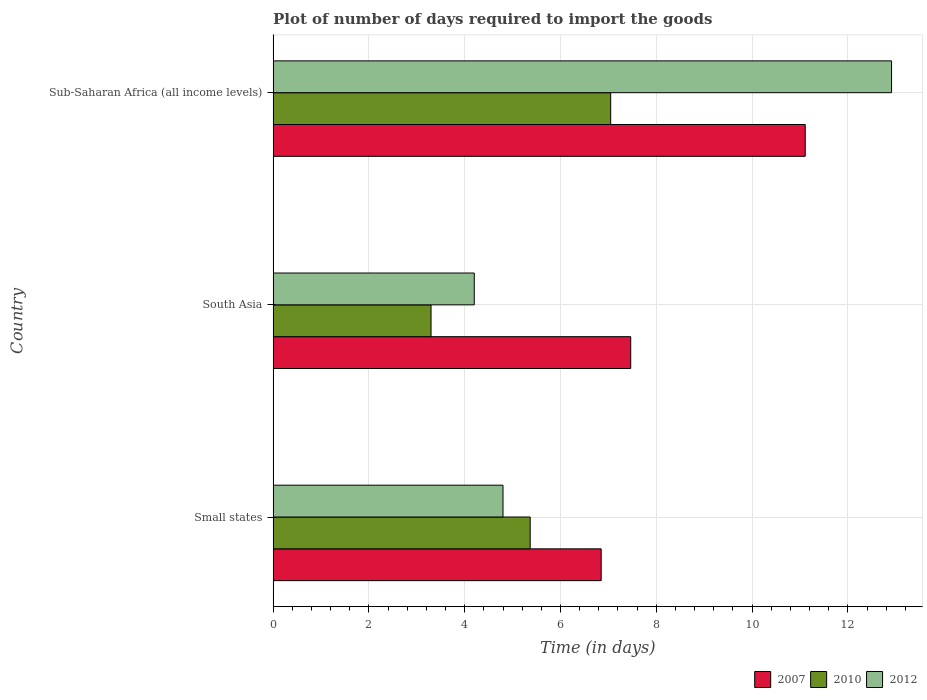How many different coloured bars are there?
Give a very brief answer. 3. Are the number of bars on each tick of the Y-axis equal?
Provide a short and direct response. Yes. How many bars are there on the 3rd tick from the top?
Give a very brief answer. 3. How many bars are there on the 3rd tick from the bottom?
Keep it short and to the point. 3. What is the label of the 1st group of bars from the top?
Your answer should be compact. Sub-Saharan Africa (all income levels). In how many cases, is the number of bars for a given country not equal to the number of legend labels?
Give a very brief answer. 0. Across all countries, what is the maximum time required to import goods in 2012?
Ensure brevity in your answer.  12.91. Across all countries, what is the minimum time required to import goods in 2010?
Provide a short and direct response. 3.3. In which country was the time required to import goods in 2007 maximum?
Offer a very short reply. Sub-Saharan Africa (all income levels). In which country was the time required to import goods in 2007 minimum?
Provide a short and direct response. Small states. What is the total time required to import goods in 2007 in the graph?
Ensure brevity in your answer.  25.43. What is the difference between the time required to import goods in 2010 in South Asia and that in Sub-Saharan Africa (all income levels)?
Offer a terse response. -3.75. What is the difference between the time required to import goods in 2010 in Sub-Saharan Africa (all income levels) and the time required to import goods in 2007 in Small states?
Your response must be concise. 0.2. What is the average time required to import goods in 2010 per country?
Provide a short and direct response. 5.24. What is the difference between the time required to import goods in 2010 and time required to import goods in 2007 in South Asia?
Your response must be concise. -4.17. What is the ratio of the time required to import goods in 2007 in Small states to that in South Asia?
Offer a very short reply. 0.92. Is the time required to import goods in 2007 in Small states less than that in Sub-Saharan Africa (all income levels)?
Make the answer very short. Yes. What is the difference between the highest and the second highest time required to import goods in 2007?
Offer a very short reply. 3.64. What is the difference between the highest and the lowest time required to import goods in 2012?
Keep it short and to the point. 8.71. In how many countries, is the time required to import goods in 2012 greater than the average time required to import goods in 2012 taken over all countries?
Offer a very short reply. 1. What does the 2nd bar from the top in South Asia represents?
Ensure brevity in your answer.  2010. Is it the case that in every country, the sum of the time required to import goods in 2012 and time required to import goods in 2007 is greater than the time required to import goods in 2010?
Give a very brief answer. Yes. How many countries are there in the graph?
Make the answer very short. 3. Where does the legend appear in the graph?
Ensure brevity in your answer.  Bottom right. What is the title of the graph?
Give a very brief answer. Plot of number of days required to import the goods. Does "1967" appear as one of the legend labels in the graph?
Your answer should be very brief. No. What is the label or title of the X-axis?
Make the answer very short. Time (in days). What is the Time (in days) of 2007 in Small states?
Your answer should be compact. 6.85. What is the Time (in days) in 2010 in Small states?
Keep it short and to the point. 5.37. What is the Time (in days) in 2012 in Small states?
Offer a terse response. 4.8. What is the Time (in days) of 2007 in South Asia?
Give a very brief answer. 7.47. What is the Time (in days) of 2010 in South Asia?
Ensure brevity in your answer.  3.3. What is the Time (in days) of 2012 in South Asia?
Offer a very short reply. 4.2. What is the Time (in days) of 2007 in Sub-Saharan Africa (all income levels)?
Your answer should be very brief. 11.11. What is the Time (in days) of 2010 in Sub-Saharan Africa (all income levels)?
Offer a terse response. 7.05. What is the Time (in days) in 2012 in Sub-Saharan Africa (all income levels)?
Keep it short and to the point. 12.91. Across all countries, what is the maximum Time (in days) of 2007?
Ensure brevity in your answer.  11.11. Across all countries, what is the maximum Time (in days) in 2010?
Your response must be concise. 7.05. Across all countries, what is the maximum Time (in days) in 2012?
Provide a short and direct response. 12.91. Across all countries, what is the minimum Time (in days) of 2007?
Ensure brevity in your answer.  6.85. Across all countries, what is the minimum Time (in days) of 2010?
Make the answer very short. 3.3. Across all countries, what is the minimum Time (in days) in 2012?
Your answer should be compact. 4.2. What is the total Time (in days) in 2007 in the graph?
Keep it short and to the point. 25.43. What is the total Time (in days) in 2010 in the graph?
Provide a short and direct response. 15.71. What is the total Time (in days) in 2012 in the graph?
Offer a very short reply. 21.91. What is the difference between the Time (in days) in 2007 in Small states and that in South Asia?
Ensure brevity in your answer.  -0.62. What is the difference between the Time (in days) of 2010 in Small states and that in South Asia?
Provide a succinct answer. 2.07. What is the difference between the Time (in days) of 2012 in Small states and that in South Asia?
Offer a terse response. 0.6. What is the difference between the Time (in days) in 2007 in Small states and that in Sub-Saharan Africa (all income levels)?
Offer a terse response. -4.26. What is the difference between the Time (in days) of 2010 in Small states and that in Sub-Saharan Africa (all income levels)?
Provide a succinct answer. -1.68. What is the difference between the Time (in days) in 2012 in Small states and that in Sub-Saharan Africa (all income levels)?
Offer a terse response. -8.11. What is the difference between the Time (in days) of 2007 in South Asia and that in Sub-Saharan Africa (all income levels)?
Your response must be concise. -3.64. What is the difference between the Time (in days) of 2010 in South Asia and that in Sub-Saharan Africa (all income levels)?
Your answer should be very brief. -3.75. What is the difference between the Time (in days) in 2012 in South Asia and that in Sub-Saharan Africa (all income levels)?
Give a very brief answer. -8.71. What is the difference between the Time (in days) of 2007 in Small states and the Time (in days) of 2010 in South Asia?
Your answer should be compact. 3.55. What is the difference between the Time (in days) of 2007 in Small states and the Time (in days) of 2012 in South Asia?
Provide a succinct answer. 2.65. What is the difference between the Time (in days) in 2010 in Small states and the Time (in days) in 2012 in South Asia?
Offer a terse response. 1.17. What is the difference between the Time (in days) in 2007 in Small states and the Time (in days) in 2010 in Sub-Saharan Africa (all income levels)?
Give a very brief answer. -0.2. What is the difference between the Time (in days) of 2007 in Small states and the Time (in days) of 2012 in Sub-Saharan Africa (all income levels)?
Your response must be concise. -6.06. What is the difference between the Time (in days) of 2010 in Small states and the Time (in days) of 2012 in Sub-Saharan Africa (all income levels)?
Your response must be concise. -7.55. What is the difference between the Time (in days) of 2007 in South Asia and the Time (in days) of 2010 in Sub-Saharan Africa (all income levels)?
Keep it short and to the point. 0.42. What is the difference between the Time (in days) in 2007 in South Asia and the Time (in days) in 2012 in Sub-Saharan Africa (all income levels)?
Your answer should be very brief. -5.45. What is the difference between the Time (in days) of 2010 in South Asia and the Time (in days) of 2012 in Sub-Saharan Africa (all income levels)?
Give a very brief answer. -9.62. What is the average Time (in days) of 2007 per country?
Make the answer very short. 8.48. What is the average Time (in days) in 2010 per country?
Ensure brevity in your answer.  5.24. What is the average Time (in days) of 2012 per country?
Your answer should be compact. 7.3. What is the difference between the Time (in days) in 2007 and Time (in days) in 2010 in Small states?
Offer a terse response. 1.48. What is the difference between the Time (in days) in 2007 and Time (in days) in 2012 in Small states?
Offer a terse response. 2.05. What is the difference between the Time (in days) in 2010 and Time (in days) in 2012 in Small states?
Offer a very short reply. 0.57. What is the difference between the Time (in days) in 2007 and Time (in days) in 2010 in South Asia?
Ensure brevity in your answer.  4.17. What is the difference between the Time (in days) in 2007 and Time (in days) in 2012 in South Asia?
Offer a terse response. 3.27. What is the difference between the Time (in days) in 2010 and Time (in days) in 2012 in South Asia?
Your response must be concise. -0.9. What is the difference between the Time (in days) in 2007 and Time (in days) in 2010 in Sub-Saharan Africa (all income levels)?
Provide a succinct answer. 4.06. What is the difference between the Time (in days) of 2007 and Time (in days) of 2012 in Sub-Saharan Africa (all income levels)?
Your response must be concise. -1.8. What is the difference between the Time (in days) of 2010 and Time (in days) of 2012 in Sub-Saharan Africa (all income levels)?
Give a very brief answer. -5.86. What is the ratio of the Time (in days) in 2007 in Small states to that in South Asia?
Give a very brief answer. 0.92. What is the ratio of the Time (in days) in 2010 in Small states to that in South Asia?
Your answer should be very brief. 1.63. What is the ratio of the Time (in days) of 2007 in Small states to that in Sub-Saharan Africa (all income levels)?
Your response must be concise. 0.62. What is the ratio of the Time (in days) in 2010 in Small states to that in Sub-Saharan Africa (all income levels)?
Offer a terse response. 0.76. What is the ratio of the Time (in days) of 2012 in Small states to that in Sub-Saharan Africa (all income levels)?
Ensure brevity in your answer.  0.37. What is the ratio of the Time (in days) in 2007 in South Asia to that in Sub-Saharan Africa (all income levels)?
Make the answer very short. 0.67. What is the ratio of the Time (in days) of 2010 in South Asia to that in Sub-Saharan Africa (all income levels)?
Provide a short and direct response. 0.47. What is the ratio of the Time (in days) of 2012 in South Asia to that in Sub-Saharan Africa (all income levels)?
Keep it short and to the point. 0.33. What is the difference between the highest and the second highest Time (in days) of 2007?
Provide a short and direct response. 3.64. What is the difference between the highest and the second highest Time (in days) in 2010?
Ensure brevity in your answer.  1.68. What is the difference between the highest and the second highest Time (in days) in 2012?
Your response must be concise. 8.11. What is the difference between the highest and the lowest Time (in days) in 2007?
Offer a terse response. 4.26. What is the difference between the highest and the lowest Time (in days) of 2010?
Ensure brevity in your answer.  3.75. What is the difference between the highest and the lowest Time (in days) of 2012?
Provide a succinct answer. 8.71. 